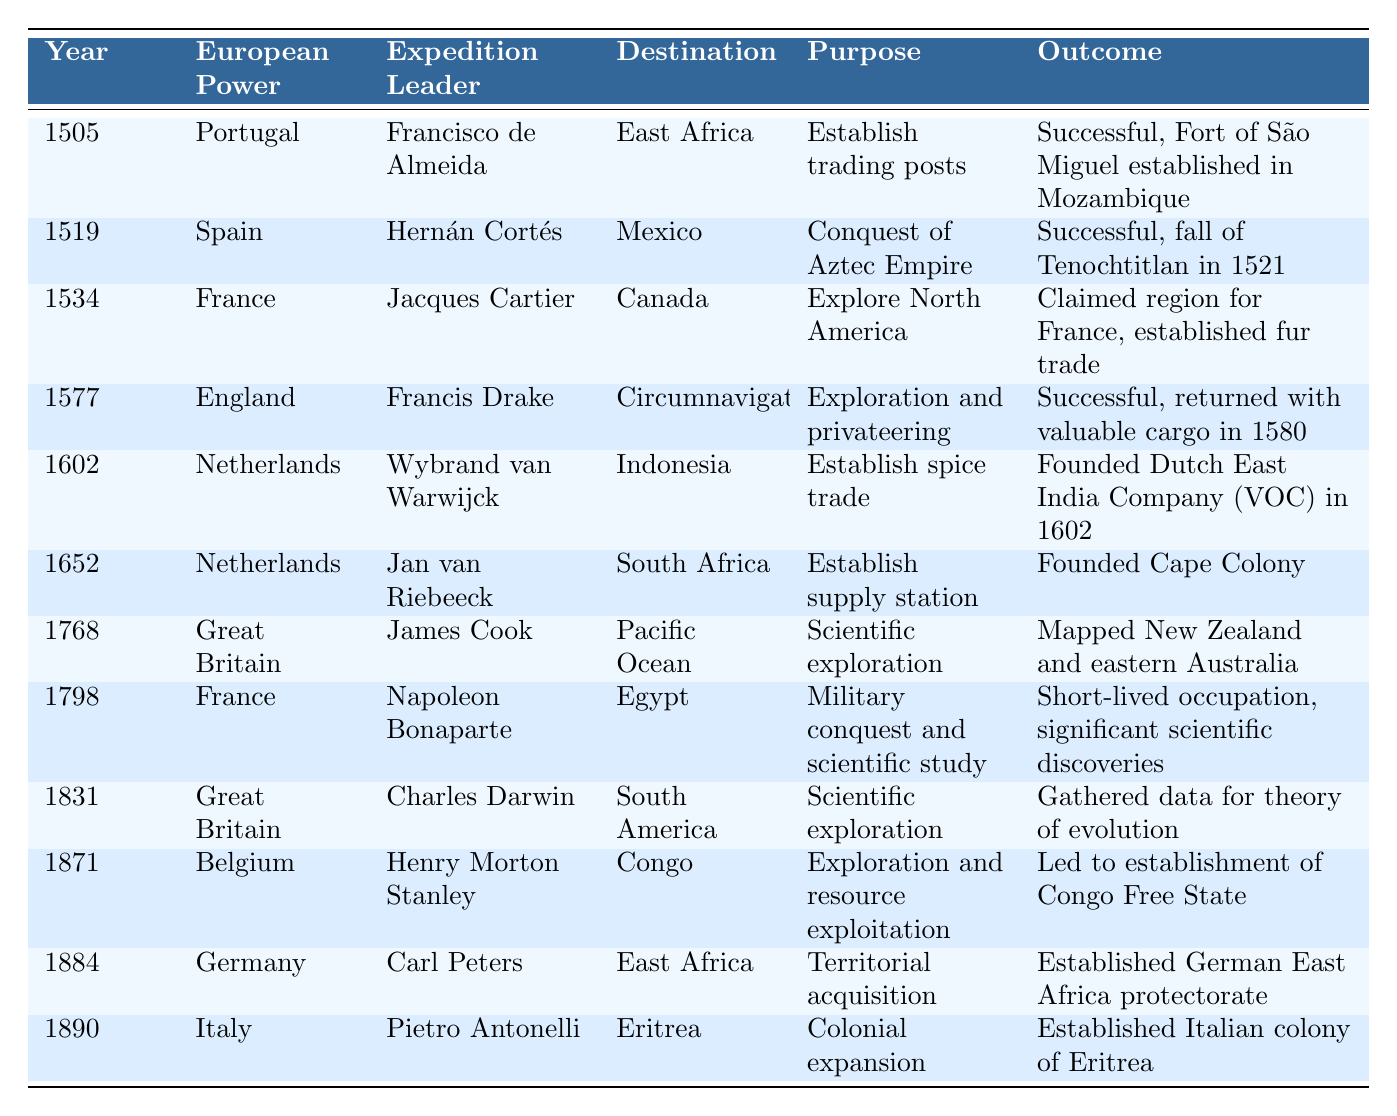What was the purpose of the expedition led by Hernán Cortés in 1519? The table lists the purpose of Hernán Cortés's expedition in 1519 as "Conquest of Aztec Empire."
Answer: Conquest of Aztec Empire Which European power established a colony in East Africa in 1884? The table indicates that Germany established a protectorate in East Africa in 1884, led by Carl Peters.
Answer: Germany How many successful expeditions are listed in the table? The table shows that there are 8 expeditions marked as successful out of the 12 missions, by counting the outcomes.
Answer: 8 What was the destination of the expedition led by James Cook in 1768? According to the table, James Cook's expedition in 1768 was directed to the Pacific Ocean.
Answer: Pacific Ocean Did the expedition by Henry Morton Stanley in 1871 lead to the establishment of a free state? Yes, the table specifies that Stanley's expedition led to the establishment of the Congo Free State.
Answer: Yes Compare the purposes of the expeditions led by Charles Darwin and James Cook. What is similar about their goals? Both expeditions focused on scientific exploration: Darwin in South America (1831) and Cook in the Pacific Ocean (1768), aimed at gathering knowledge and mapping.
Answer: Both aimed at scientific exploration Which expedition had the earliest date, and what was its outcome? The earliest expedition is by Francisco de Almeida in 1505, which was successful and resulted in the establishment of the Fort of São Miguel in Mozambique.
Answer: Successful, established Fort of São Miguel Based on the table, which expedition resulted in significant scientific discoveries during a military conquest? The expedition led by Napoleon Bonaparte in 1798 to Egypt was both a military conquest and yielded significant scientific discoveries.
Answer: Napoleon Bonaparte's expedition Identify how many expeditions were led by the Netherlands and summarize their purposes. The Netherlands had two expeditions listed, one in 1602 for spice trade and another in 1652 to establish a supply station, aiming to facilitate trade and establish colonial presence.
Answer: 2 expeditions; spice trade and supply station What is the relationship between the year of the expedition and the establishment of trading posts, according to the table? The expeditions established trading posts in the years 1505 (Portugal) and 1602 (Netherlands), indicating a trend of establishing trade networks early in colonial expansion.
Answer: They were established in 1505 and 1602 How did the outcomes of the expeditions differ between France’s explorations in Canada and Egypt? France’s expedition in Canada (1534) resulted in claiming land and establishing a fur trade, while the expedition in Egypt (1798) led to a short-lived occupation with scientific discoveries but no long-term territorial gain.
Answer: Different outcomes: trade vs. short-lived occupation 